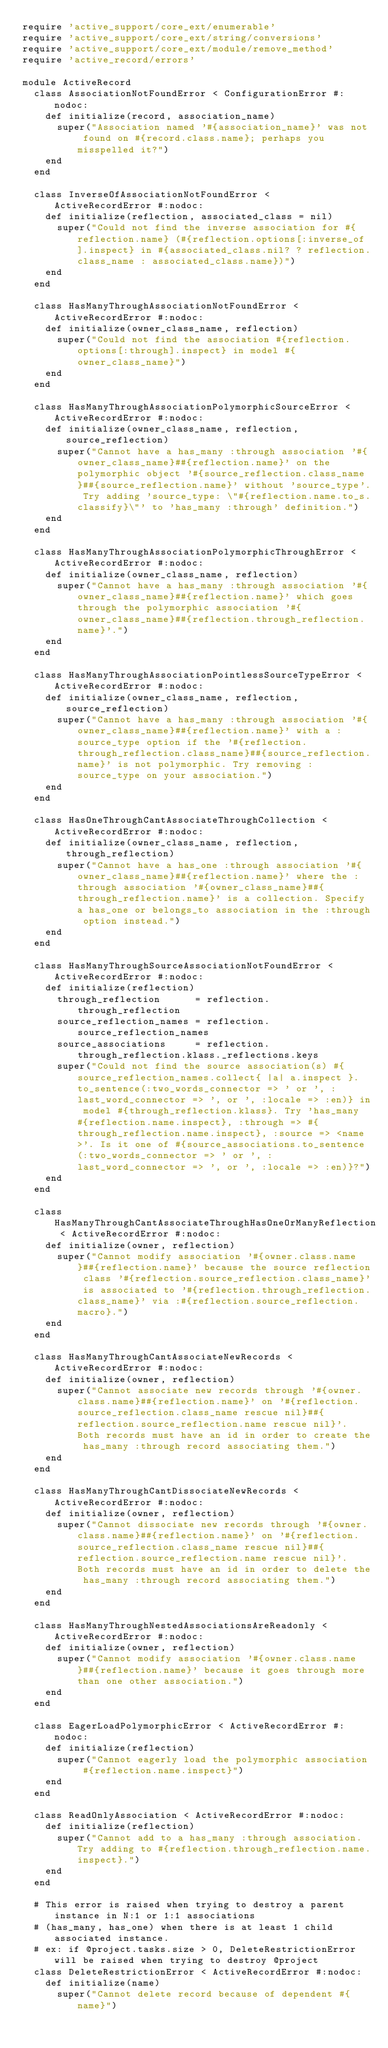Convert code to text. <code><loc_0><loc_0><loc_500><loc_500><_Ruby_>require 'active_support/core_ext/enumerable'
require 'active_support/core_ext/string/conversions'
require 'active_support/core_ext/module/remove_method'
require 'active_record/errors'

module ActiveRecord
  class AssociationNotFoundError < ConfigurationError #:nodoc:
    def initialize(record, association_name)
      super("Association named '#{association_name}' was not found on #{record.class.name}; perhaps you misspelled it?")
    end
  end

  class InverseOfAssociationNotFoundError < ActiveRecordError #:nodoc:
    def initialize(reflection, associated_class = nil)
      super("Could not find the inverse association for #{reflection.name} (#{reflection.options[:inverse_of].inspect} in #{associated_class.nil? ? reflection.class_name : associated_class.name})")
    end
  end

  class HasManyThroughAssociationNotFoundError < ActiveRecordError #:nodoc:
    def initialize(owner_class_name, reflection)
      super("Could not find the association #{reflection.options[:through].inspect} in model #{owner_class_name}")
    end
  end

  class HasManyThroughAssociationPolymorphicSourceError < ActiveRecordError #:nodoc:
    def initialize(owner_class_name, reflection, source_reflection)
      super("Cannot have a has_many :through association '#{owner_class_name}##{reflection.name}' on the polymorphic object '#{source_reflection.class_name}##{source_reflection.name}' without 'source_type'. Try adding 'source_type: \"#{reflection.name.to_s.classify}\"' to 'has_many :through' definition.")
    end
  end

  class HasManyThroughAssociationPolymorphicThroughError < ActiveRecordError #:nodoc:
    def initialize(owner_class_name, reflection)
      super("Cannot have a has_many :through association '#{owner_class_name}##{reflection.name}' which goes through the polymorphic association '#{owner_class_name}##{reflection.through_reflection.name}'.")
    end
  end

  class HasManyThroughAssociationPointlessSourceTypeError < ActiveRecordError #:nodoc:
    def initialize(owner_class_name, reflection, source_reflection)
      super("Cannot have a has_many :through association '#{owner_class_name}##{reflection.name}' with a :source_type option if the '#{reflection.through_reflection.class_name}##{source_reflection.name}' is not polymorphic. Try removing :source_type on your association.")
    end
  end

  class HasOneThroughCantAssociateThroughCollection < ActiveRecordError #:nodoc:
    def initialize(owner_class_name, reflection, through_reflection)
      super("Cannot have a has_one :through association '#{owner_class_name}##{reflection.name}' where the :through association '#{owner_class_name}##{through_reflection.name}' is a collection. Specify a has_one or belongs_to association in the :through option instead.")
    end
  end

  class HasManyThroughSourceAssociationNotFoundError < ActiveRecordError #:nodoc:
    def initialize(reflection)
      through_reflection      = reflection.through_reflection
      source_reflection_names = reflection.source_reflection_names
      source_associations     = reflection.through_reflection.klass._reflections.keys
      super("Could not find the source association(s) #{source_reflection_names.collect{ |a| a.inspect }.to_sentence(:two_words_connector => ' or ', :last_word_connector => ', or ', :locale => :en)} in model #{through_reflection.klass}. Try 'has_many #{reflection.name.inspect}, :through => #{through_reflection.name.inspect}, :source => <name>'. Is it one of #{source_associations.to_sentence(:two_words_connector => ' or ', :last_word_connector => ', or ', :locale => :en)}?")
    end
  end

  class HasManyThroughCantAssociateThroughHasOneOrManyReflection < ActiveRecordError #:nodoc:
    def initialize(owner, reflection)
      super("Cannot modify association '#{owner.class.name}##{reflection.name}' because the source reflection class '#{reflection.source_reflection.class_name}' is associated to '#{reflection.through_reflection.class_name}' via :#{reflection.source_reflection.macro}.")
    end
  end

  class HasManyThroughCantAssociateNewRecords < ActiveRecordError #:nodoc:
    def initialize(owner, reflection)
      super("Cannot associate new records through '#{owner.class.name}##{reflection.name}' on '#{reflection.source_reflection.class_name rescue nil}##{reflection.source_reflection.name rescue nil}'. Both records must have an id in order to create the has_many :through record associating them.")
    end
  end

  class HasManyThroughCantDissociateNewRecords < ActiveRecordError #:nodoc:
    def initialize(owner, reflection)
      super("Cannot dissociate new records through '#{owner.class.name}##{reflection.name}' on '#{reflection.source_reflection.class_name rescue nil}##{reflection.source_reflection.name rescue nil}'. Both records must have an id in order to delete the has_many :through record associating them.")
    end
  end

  class HasManyThroughNestedAssociationsAreReadonly < ActiveRecordError #:nodoc:
    def initialize(owner, reflection)
      super("Cannot modify association '#{owner.class.name}##{reflection.name}' because it goes through more than one other association.")
    end
  end

  class EagerLoadPolymorphicError < ActiveRecordError #:nodoc:
    def initialize(reflection)
      super("Cannot eagerly load the polymorphic association #{reflection.name.inspect}")
    end
  end

  class ReadOnlyAssociation < ActiveRecordError #:nodoc:
    def initialize(reflection)
      super("Cannot add to a has_many :through association. Try adding to #{reflection.through_reflection.name.inspect}.")
    end
  end

  # This error is raised when trying to destroy a parent instance in N:1 or 1:1 associations
  # (has_many, has_one) when there is at least 1 child associated instance.
  # ex: if @project.tasks.size > 0, DeleteRestrictionError will be raised when trying to destroy @project
  class DeleteRestrictionError < ActiveRecordError #:nodoc:
    def initialize(name)
      super("Cannot delete record because of dependent #{name}")</code> 